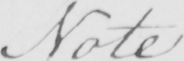What is written in this line of handwriting? Note 